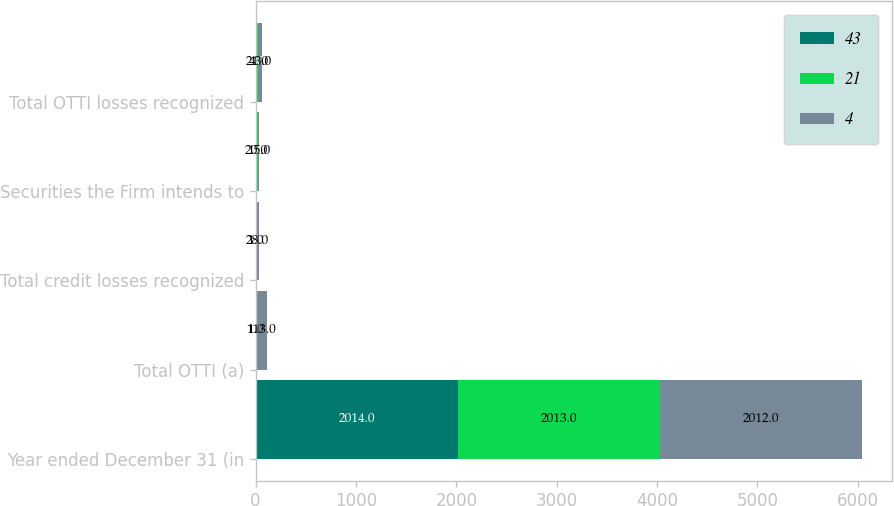Convert chart to OTSL. <chart><loc_0><loc_0><loc_500><loc_500><stacked_bar_chart><ecel><fcel>Year ended December 31 (in<fcel>Total OTTI (a)<fcel>Total credit losses recognized<fcel>Securities the Firm intends to<fcel>Total OTTI losses recognized<nl><fcel>43<fcel>2014<fcel>2<fcel>2<fcel>2<fcel>4<nl><fcel>21<fcel>2013<fcel>1<fcel>1<fcel>20<fcel>21<nl><fcel>4<fcel>2012<fcel>113<fcel>28<fcel>15<fcel>43<nl></chart> 